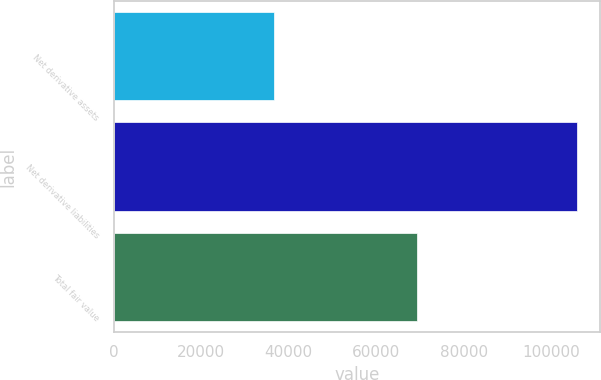Convert chart. <chart><loc_0><loc_0><loc_500><loc_500><bar_chart><fcel>Net derivative assets<fcel>Net derivative liabilities<fcel>Total fair value<nl><fcel>36661<fcel>105934<fcel>69273<nl></chart> 